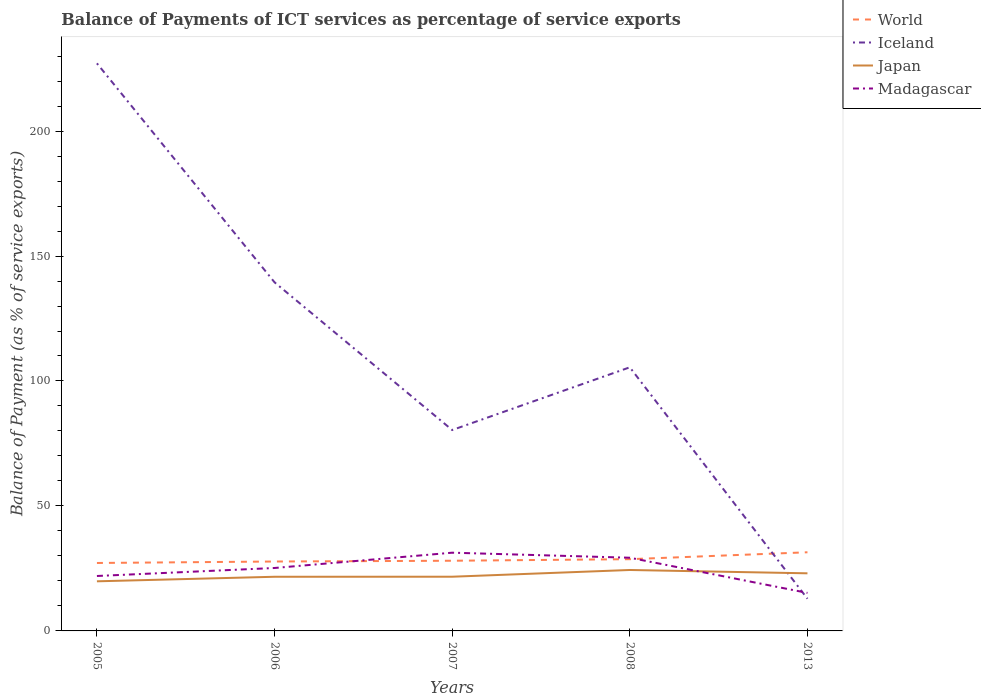Is the number of lines equal to the number of legend labels?
Offer a terse response. Yes. Across all years, what is the maximum balance of payments of ICT services in Japan?
Ensure brevity in your answer.  19.85. What is the total balance of payments of ICT services in Madagascar in the graph?
Keep it short and to the point. -9.32. What is the difference between the highest and the second highest balance of payments of ICT services in Madagascar?
Your answer should be very brief. 16.09. Are the values on the major ticks of Y-axis written in scientific E-notation?
Your answer should be very brief. No. Where does the legend appear in the graph?
Provide a short and direct response. Top right. What is the title of the graph?
Provide a short and direct response. Balance of Payments of ICT services as percentage of service exports. Does "St. Kitts and Nevis" appear as one of the legend labels in the graph?
Provide a succinct answer. No. What is the label or title of the X-axis?
Keep it short and to the point. Years. What is the label or title of the Y-axis?
Provide a short and direct response. Balance of Payment (as % of service exports). What is the Balance of Payment (as % of service exports) in World in 2005?
Your answer should be very brief. 27.19. What is the Balance of Payment (as % of service exports) of Iceland in 2005?
Ensure brevity in your answer.  227.09. What is the Balance of Payment (as % of service exports) in Japan in 2005?
Ensure brevity in your answer.  19.85. What is the Balance of Payment (as % of service exports) in Madagascar in 2005?
Offer a very short reply. 21.98. What is the Balance of Payment (as % of service exports) of World in 2006?
Ensure brevity in your answer.  27.77. What is the Balance of Payment (as % of service exports) of Iceland in 2006?
Offer a very short reply. 139.47. What is the Balance of Payment (as % of service exports) of Japan in 2006?
Provide a succinct answer. 21.67. What is the Balance of Payment (as % of service exports) of Madagascar in 2006?
Give a very brief answer. 25.18. What is the Balance of Payment (as % of service exports) in World in 2007?
Provide a short and direct response. 28.08. What is the Balance of Payment (as % of service exports) of Iceland in 2007?
Offer a very short reply. 80.38. What is the Balance of Payment (as % of service exports) of Japan in 2007?
Your answer should be compact. 21.69. What is the Balance of Payment (as % of service exports) in Madagascar in 2007?
Provide a succinct answer. 31.3. What is the Balance of Payment (as % of service exports) of World in 2008?
Your answer should be compact. 28.7. What is the Balance of Payment (as % of service exports) in Iceland in 2008?
Your answer should be very brief. 105.47. What is the Balance of Payment (as % of service exports) of Japan in 2008?
Offer a very short reply. 24.38. What is the Balance of Payment (as % of service exports) of Madagascar in 2008?
Offer a terse response. 29.28. What is the Balance of Payment (as % of service exports) in World in 2013?
Give a very brief answer. 31.47. What is the Balance of Payment (as % of service exports) of Iceland in 2013?
Your answer should be very brief. 12.89. What is the Balance of Payment (as % of service exports) in Japan in 2013?
Ensure brevity in your answer.  23.05. What is the Balance of Payment (as % of service exports) of Madagascar in 2013?
Your response must be concise. 15.21. Across all years, what is the maximum Balance of Payment (as % of service exports) in World?
Your answer should be compact. 31.47. Across all years, what is the maximum Balance of Payment (as % of service exports) of Iceland?
Your answer should be compact. 227.09. Across all years, what is the maximum Balance of Payment (as % of service exports) of Japan?
Offer a very short reply. 24.38. Across all years, what is the maximum Balance of Payment (as % of service exports) of Madagascar?
Make the answer very short. 31.3. Across all years, what is the minimum Balance of Payment (as % of service exports) of World?
Your response must be concise. 27.19. Across all years, what is the minimum Balance of Payment (as % of service exports) in Iceland?
Keep it short and to the point. 12.89. Across all years, what is the minimum Balance of Payment (as % of service exports) of Japan?
Your answer should be very brief. 19.85. Across all years, what is the minimum Balance of Payment (as % of service exports) in Madagascar?
Provide a short and direct response. 15.21. What is the total Balance of Payment (as % of service exports) in World in the graph?
Give a very brief answer. 143.21. What is the total Balance of Payment (as % of service exports) of Iceland in the graph?
Offer a terse response. 565.31. What is the total Balance of Payment (as % of service exports) of Japan in the graph?
Offer a very short reply. 110.63. What is the total Balance of Payment (as % of service exports) in Madagascar in the graph?
Give a very brief answer. 122.95. What is the difference between the Balance of Payment (as % of service exports) in World in 2005 and that in 2006?
Offer a terse response. -0.59. What is the difference between the Balance of Payment (as % of service exports) in Iceland in 2005 and that in 2006?
Offer a very short reply. 87.62. What is the difference between the Balance of Payment (as % of service exports) in Japan in 2005 and that in 2006?
Your response must be concise. -1.82. What is the difference between the Balance of Payment (as % of service exports) of Madagascar in 2005 and that in 2006?
Offer a terse response. -3.2. What is the difference between the Balance of Payment (as % of service exports) in World in 2005 and that in 2007?
Your answer should be very brief. -0.9. What is the difference between the Balance of Payment (as % of service exports) of Iceland in 2005 and that in 2007?
Provide a succinct answer. 146.71. What is the difference between the Balance of Payment (as % of service exports) of Japan in 2005 and that in 2007?
Your response must be concise. -1.84. What is the difference between the Balance of Payment (as % of service exports) in Madagascar in 2005 and that in 2007?
Offer a terse response. -9.32. What is the difference between the Balance of Payment (as % of service exports) in World in 2005 and that in 2008?
Ensure brevity in your answer.  -1.52. What is the difference between the Balance of Payment (as % of service exports) of Iceland in 2005 and that in 2008?
Your answer should be very brief. 121.62. What is the difference between the Balance of Payment (as % of service exports) in Japan in 2005 and that in 2008?
Your answer should be compact. -4.53. What is the difference between the Balance of Payment (as % of service exports) in Madagascar in 2005 and that in 2008?
Make the answer very short. -7.31. What is the difference between the Balance of Payment (as % of service exports) of World in 2005 and that in 2013?
Offer a terse response. -4.28. What is the difference between the Balance of Payment (as % of service exports) of Iceland in 2005 and that in 2013?
Offer a very short reply. 214.2. What is the difference between the Balance of Payment (as % of service exports) in Japan in 2005 and that in 2013?
Give a very brief answer. -3.2. What is the difference between the Balance of Payment (as % of service exports) of Madagascar in 2005 and that in 2013?
Provide a short and direct response. 6.77. What is the difference between the Balance of Payment (as % of service exports) of World in 2006 and that in 2007?
Your answer should be very brief. -0.31. What is the difference between the Balance of Payment (as % of service exports) of Iceland in 2006 and that in 2007?
Provide a short and direct response. 59.09. What is the difference between the Balance of Payment (as % of service exports) in Japan in 2006 and that in 2007?
Your answer should be compact. -0.02. What is the difference between the Balance of Payment (as % of service exports) of Madagascar in 2006 and that in 2007?
Offer a very short reply. -6.12. What is the difference between the Balance of Payment (as % of service exports) of World in 2006 and that in 2008?
Keep it short and to the point. -0.93. What is the difference between the Balance of Payment (as % of service exports) in Iceland in 2006 and that in 2008?
Ensure brevity in your answer.  34. What is the difference between the Balance of Payment (as % of service exports) in Japan in 2006 and that in 2008?
Offer a very short reply. -2.72. What is the difference between the Balance of Payment (as % of service exports) in Madagascar in 2006 and that in 2008?
Give a very brief answer. -4.1. What is the difference between the Balance of Payment (as % of service exports) of World in 2006 and that in 2013?
Offer a very short reply. -3.7. What is the difference between the Balance of Payment (as % of service exports) in Iceland in 2006 and that in 2013?
Give a very brief answer. 126.59. What is the difference between the Balance of Payment (as % of service exports) in Japan in 2006 and that in 2013?
Offer a terse response. -1.38. What is the difference between the Balance of Payment (as % of service exports) of Madagascar in 2006 and that in 2013?
Ensure brevity in your answer.  9.97. What is the difference between the Balance of Payment (as % of service exports) in World in 2007 and that in 2008?
Give a very brief answer. -0.62. What is the difference between the Balance of Payment (as % of service exports) in Iceland in 2007 and that in 2008?
Offer a terse response. -25.09. What is the difference between the Balance of Payment (as % of service exports) in Japan in 2007 and that in 2008?
Offer a terse response. -2.7. What is the difference between the Balance of Payment (as % of service exports) in Madagascar in 2007 and that in 2008?
Your response must be concise. 2.02. What is the difference between the Balance of Payment (as % of service exports) of World in 2007 and that in 2013?
Your response must be concise. -3.39. What is the difference between the Balance of Payment (as % of service exports) in Iceland in 2007 and that in 2013?
Provide a short and direct response. 67.5. What is the difference between the Balance of Payment (as % of service exports) of Japan in 2007 and that in 2013?
Your answer should be compact. -1.36. What is the difference between the Balance of Payment (as % of service exports) of Madagascar in 2007 and that in 2013?
Your response must be concise. 16.09. What is the difference between the Balance of Payment (as % of service exports) in World in 2008 and that in 2013?
Make the answer very short. -2.77. What is the difference between the Balance of Payment (as % of service exports) of Iceland in 2008 and that in 2013?
Offer a very short reply. 92.59. What is the difference between the Balance of Payment (as % of service exports) of Japan in 2008 and that in 2013?
Ensure brevity in your answer.  1.33. What is the difference between the Balance of Payment (as % of service exports) in Madagascar in 2008 and that in 2013?
Provide a short and direct response. 14.07. What is the difference between the Balance of Payment (as % of service exports) in World in 2005 and the Balance of Payment (as % of service exports) in Iceland in 2006?
Ensure brevity in your answer.  -112.29. What is the difference between the Balance of Payment (as % of service exports) in World in 2005 and the Balance of Payment (as % of service exports) in Japan in 2006?
Keep it short and to the point. 5.52. What is the difference between the Balance of Payment (as % of service exports) of World in 2005 and the Balance of Payment (as % of service exports) of Madagascar in 2006?
Ensure brevity in your answer.  2. What is the difference between the Balance of Payment (as % of service exports) of Iceland in 2005 and the Balance of Payment (as % of service exports) of Japan in 2006?
Your answer should be compact. 205.43. What is the difference between the Balance of Payment (as % of service exports) of Iceland in 2005 and the Balance of Payment (as % of service exports) of Madagascar in 2006?
Your response must be concise. 201.91. What is the difference between the Balance of Payment (as % of service exports) in Japan in 2005 and the Balance of Payment (as % of service exports) in Madagascar in 2006?
Keep it short and to the point. -5.33. What is the difference between the Balance of Payment (as % of service exports) in World in 2005 and the Balance of Payment (as % of service exports) in Iceland in 2007?
Give a very brief answer. -53.2. What is the difference between the Balance of Payment (as % of service exports) in World in 2005 and the Balance of Payment (as % of service exports) in Japan in 2007?
Offer a very short reply. 5.5. What is the difference between the Balance of Payment (as % of service exports) of World in 2005 and the Balance of Payment (as % of service exports) of Madagascar in 2007?
Your answer should be very brief. -4.12. What is the difference between the Balance of Payment (as % of service exports) in Iceland in 2005 and the Balance of Payment (as % of service exports) in Japan in 2007?
Give a very brief answer. 205.41. What is the difference between the Balance of Payment (as % of service exports) of Iceland in 2005 and the Balance of Payment (as % of service exports) of Madagascar in 2007?
Make the answer very short. 195.79. What is the difference between the Balance of Payment (as % of service exports) of Japan in 2005 and the Balance of Payment (as % of service exports) of Madagascar in 2007?
Your answer should be compact. -11.45. What is the difference between the Balance of Payment (as % of service exports) in World in 2005 and the Balance of Payment (as % of service exports) in Iceland in 2008?
Offer a terse response. -78.29. What is the difference between the Balance of Payment (as % of service exports) of World in 2005 and the Balance of Payment (as % of service exports) of Japan in 2008?
Provide a short and direct response. 2.8. What is the difference between the Balance of Payment (as % of service exports) of World in 2005 and the Balance of Payment (as % of service exports) of Madagascar in 2008?
Provide a succinct answer. -2.1. What is the difference between the Balance of Payment (as % of service exports) of Iceland in 2005 and the Balance of Payment (as % of service exports) of Japan in 2008?
Your response must be concise. 202.71. What is the difference between the Balance of Payment (as % of service exports) of Iceland in 2005 and the Balance of Payment (as % of service exports) of Madagascar in 2008?
Provide a short and direct response. 197.81. What is the difference between the Balance of Payment (as % of service exports) in Japan in 2005 and the Balance of Payment (as % of service exports) in Madagascar in 2008?
Provide a succinct answer. -9.43. What is the difference between the Balance of Payment (as % of service exports) in World in 2005 and the Balance of Payment (as % of service exports) in Iceland in 2013?
Your answer should be compact. 14.3. What is the difference between the Balance of Payment (as % of service exports) in World in 2005 and the Balance of Payment (as % of service exports) in Japan in 2013?
Your answer should be compact. 4.14. What is the difference between the Balance of Payment (as % of service exports) of World in 2005 and the Balance of Payment (as % of service exports) of Madagascar in 2013?
Your answer should be very brief. 11.97. What is the difference between the Balance of Payment (as % of service exports) of Iceland in 2005 and the Balance of Payment (as % of service exports) of Japan in 2013?
Provide a succinct answer. 204.04. What is the difference between the Balance of Payment (as % of service exports) in Iceland in 2005 and the Balance of Payment (as % of service exports) in Madagascar in 2013?
Offer a terse response. 211.88. What is the difference between the Balance of Payment (as % of service exports) in Japan in 2005 and the Balance of Payment (as % of service exports) in Madagascar in 2013?
Offer a very short reply. 4.64. What is the difference between the Balance of Payment (as % of service exports) of World in 2006 and the Balance of Payment (as % of service exports) of Iceland in 2007?
Keep it short and to the point. -52.61. What is the difference between the Balance of Payment (as % of service exports) in World in 2006 and the Balance of Payment (as % of service exports) in Japan in 2007?
Your answer should be very brief. 6.08. What is the difference between the Balance of Payment (as % of service exports) in World in 2006 and the Balance of Payment (as % of service exports) in Madagascar in 2007?
Make the answer very short. -3.53. What is the difference between the Balance of Payment (as % of service exports) in Iceland in 2006 and the Balance of Payment (as % of service exports) in Japan in 2007?
Make the answer very short. 117.79. What is the difference between the Balance of Payment (as % of service exports) in Iceland in 2006 and the Balance of Payment (as % of service exports) in Madagascar in 2007?
Provide a short and direct response. 108.17. What is the difference between the Balance of Payment (as % of service exports) of Japan in 2006 and the Balance of Payment (as % of service exports) of Madagascar in 2007?
Your response must be concise. -9.63. What is the difference between the Balance of Payment (as % of service exports) in World in 2006 and the Balance of Payment (as % of service exports) in Iceland in 2008?
Offer a very short reply. -77.7. What is the difference between the Balance of Payment (as % of service exports) in World in 2006 and the Balance of Payment (as % of service exports) in Japan in 2008?
Provide a succinct answer. 3.39. What is the difference between the Balance of Payment (as % of service exports) in World in 2006 and the Balance of Payment (as % of service exports) in Madagascar in 2008?
Your answer should be very brief. -1.51. What is the difference between the Balance of Payment (as % of service exports) in Iceland in 2006 and the Balance of Payment (as % of service exports) in Japan in 2008?
Ensure brevity in your answer.  115.09. What is the difference between the Balance of Payment (as % of service exports) in Iceland in 2006 and the Balance of Payment (as % of service exports) in Madagascar in 2008?
Keep it short and to the point. 110.19. What is the difference between the Balance of Payment (as % of service exports) of Japan in 2006 and the Balance of Payment (as % of service exports) of Madagascar in 2008?
Offer a terse response. -7.62. What is the difference between the Balance of Payment (as % of service exports) of World in 2006 and the Balance of Payment (as % of service exports) of Iceland in 2013?
Make the answer very short. 14.88. What is the difference between the Balance of Payment (as % of service exports) of World in 2006 and the Balance of Payment (as % of service exports) of Japan in 2013?
Your answer should be compact. 4.72. What is the difference between the Balance of Payment (as % of service exports) of World in 2006 and the Balance of Payment (as % of service exports) of Madagascar in 2013?
Give a very brief answer. 12.56. What is the difference between the Balance of Payment (as % of service exports) of Iceland in 2006 and the Balance of Payment (as % of service exports) of Japan in 2013?
Offer a terse response. 116.43. What is the difference between the Balance of Payment (as % of service exports) of Iceland in 2006 and the Balance of Payment (as % of service exports) of Madagascar in 2013?
Your response must be concise. 124.26. What is the difference between the Balance of Payment (as % of service exports) in Japan in 2006 and the Balance of Payment (as % of service exports) in Madagascar in 2013?
Offer a very short reply. 6.46. What is the difference between the Balance of Payment (as % of service exports) of World in 2007 and the Balance of Payment (as % of service exports) of Iceland in 2008?
Provide a short and direct response. -77.39. What is the difference between the Balance of Payment (as % of service exports) in World in 2007 and the Balance of Payment (as % of service exports) in Japan in 2008?
Your answer should be compact. 3.7. What is the difference between the Balance of Payment (as % of service exports) in World in 2007 and the Balance of Payment (as % of service exports) in Madagascar in 2008?
Your answer should be very brief. -1.2. What is the difference between the Balance of Payment (as % of service exports) of Iceland in 2007 and the Balance of Payment (as % of service exports) of Japan in 2008?
Your answer should be very brief. 56. What is the difference between the Balance of Payment (as % of service exports) in Iceland in 2007 and the Balance of Payment (as % of service exports) in Madagascar in 2008?
Keep it short and to the point. 51.1. What is the difference between the Balance of Payment (as % of service exports) in Japan in 2007 and the Balance of Payment (as % of service exports) in Madagascar in 2008?
Your response must be concise. -7.6. What is the difference between the Balance of Payment (as % of service exports) of World in 2007 and the Balance of Payment (as % of service exports) of Iceland in 2013?
Your answer should be very brief. 15.19. What is the difference between the Balance of Payment (as % of service exports) in World in 2007 and the Balance of Payment (as % of service exports) in Japan in 2013?
Your answer should be very brief. 5.03. What is the difference between the Balance of Payment (as % of service exports) in World in 2007 and the Balance of Payment (as % of service exports) in Madagascar in 2013?
Ensure brevity in your answer.  12.87. What is the difference between the Balance of Payment (as % of service exports) of Iceland in 2007 and the Balance of Payment (as % of service exports) of Japan in 2013?
Provide a short and direct response. 57.34. What is the difference between the Balance of Payment (as % of service exports) in Iceland in 2007 and the Balance of Payment (as % of service exports) in Madagascar in 2013?
Your response must be concise. 65.17. What is the difference between the Balance of Payment (as % of service exports) in Japan in 2007 and the Balance of Payment (as % of service exports) in Madagascar in 2013?
Give a very brief answer. 6.47. What is the difference between the Balance of Payment (as % of service exports) of World in 2008 and the Balance of Payment (as % of service exports) of Iceland in 2013?
Keep it short and to the point. 15.81. What is the difference between the Balance of Payment (as % of service exports) of World in 2008 and the Balance of Payment (as % of service exports) of Japan in 2013?
Ensure brevity in your answer.  5.65. What is the difference between the Balance of Payment (as % of service exports) of World in 2008 and the Balance of Payment (as % of service exports) of Madagascar in 2013?
Your answer should be very brief. 13.49. What is the difference between the Balance of Payment (as % of service exports) in Iceland in 2008 and the Balance of Payment (as % of service exports) in Japan in 2013?
Make the answer very short. 82.43. What is the difference between the Balance of Payment (as % of service exports) of Iceland in 2008 and the Balance of Payment (as % of service exports) of Madagascar in 2013?
Offer a very short reply. 90.26. What is the difference between the Balance of Payment (as % of service exports) of Japan in 2008 and the Balance of Payment (as % of service exports) of Madagascar in 2013?
Offer a terse response. 9.17. What is the average Balance of Payment (as % of service exports) of World per year?
Your answer should be very brief. 28.64. What is the average Balance of Payment (as % of service exports) of Iceland per year?
Your answer should be very brief. 113.06. What is the average Balance of Payment (as % of service exports) of Japan per year?
Keep it short and to the point. 22.13. What is the average Balance of Payment (as % of service exports) of Madagascar per year?
Your response must be concise. 24.59. In the year 2005, what is the difference between the Balance of Payment (as % of service exports) of World and Balance of Payment (as % of service exports) of Iceland?
Your answer should be compact. -199.91. In the year 2005, what is the difference between the Balance of Payment (as % of service exports) in World and Balance of Payment (as % of service exports) in Japan?
Your answer should be very brief. 7.34. In the year 2005, what is the difference between the Balance of Payment (as % of service exports) in World and Balance of Payment (as % of service exports) in Madagascar?
Your answer should be compact. 5.21. In the year 2005, what is the difference between the Balance of Payment (as % of service exports) in Iceland and Balance of Payment (as % of service exports) in Japan?
Provide a short and direct response. 207.24. In the year 2005, what is the difference between the Balance of Payment (as % of service exports) in Iceland and Balance of Payment (as % of service exports) in Madagascar?
Make the answer very short. 205.11. In the year 2005, what is the difference between the Balance of Payment (as % of service exports) in Japan and Balance of Payment (as % of service exports) in Madagascar?
Your response must be concise. -2.13. In the year 2006, what is the difference between the Balance of Payment (as % of service exports) of World and Balance of Payment (as % of service exports) of Iceland?
Provide a short and direct response. -111.7. In the year 2006, what is the difference between the Balance of Payment (as % of service exports) in World and Balance of Payment (as % of service exports) in Japan?
Ensure brevity in your answer.  6.1. In the year 2006, what is the difference between the Balance of Payment (as % of service exports) in World and Balance of Payment (as % of service exports) in Madagascar?
Your answer should be compact. 2.59. In the year 2006, what is the difference between the Balance of Payment (as % of service exports) of Iceland and Balance of Payment (as % of service exports) of Japan?
Your answer should be compact. 117.81. In the year 2006, what is the difference between the Balance of Payment (as % of service exports) of Iceland and Balance of Payment (as % of service exports) of Madagascar?
Your answer should be compact. 114.29. In the year 2006, what is the difference between the Balance of Payment (as % of service exports) in Japan and Balance of Payment (as % of service exports) in Madagascar?
Give a very brief answer. -3.51. In the year 2007, what is the difference between the Balance of Payment (as % of service exports) of World and Balance of Payment (as % of service exports) of Iceland?
Your answer should be very brief. -52.3. In the year 2007, what is the difference between the Balance of Payment (as % of service exports) in World and Balance of Payment (as % of service exports) in Japan?
Offer a very short reply. 6.39. In the year 2007, what is the difference between the Balance of Payment (as % of service exports) in World and Balance of Payment (as % of service exports) in Madagascar?
Provide a succinct answer. -3.22. In the year 2007, what is the difference between the Balance of Payment (as % of service exports) in Iceland and Balance of Payment (as % of service exports) in Japan?
Your answer should be very brief. 58.7. In the year 2007, what is the difference between the Balance of Payment (as % of service exports) in Iceland and Balance of Payment (as % of service exports) in Madagascar?
Offer a very short reply. 49.08. In the year 2007, what is the difference between the Balance of Payment (as % of service exports) of Japan and Balance of Payment (as % of service exports) of Madagascar?
Provide a succinct answer. -9.62. In the year 2008, what is the difference between the Balance of Payment (as % of service exports) in World and Balance of Payment (as % of service exports) in Iceland?
Your answer should be very brief. -76.77. In the year 2008, what is the difference between the Balance of Payment (as % of service exports) in World and Balance of Payment (as % of service exports) in Japan?
Ensure brevity in your answer.  4.32. In the year 2008, what is the difference between the Balance of Payment (as % of service exports) in World and Balance of Payment (as % of service exports) in Madagascar?
Ensure brevity in your answer.  -0.58. In the year 2008, what is the difference between the Balance of Payment (as % of service exports) of Iceland and Balance of Payment (as % of service exports) of Japan?
Provide a succinct answer. 81.09. In the year 2008, what is the difference between the Balance of Payment (as % of service exports) in Iceland and Balance of Payment (as % of service exports) in Madagascar?
Offer a terse response. 76.19. In the year 2008, what is the difference between the Balance of Payment (as % of service exports) of Japan and Balance of Payment (as % of service exports) of Madagascar?
Provide a succinct answer. -4.9. In the year 2013, what is the difference between the Balance of Payment (as % of service exports) in World and Balance of Payment (as % of service exports) in Iceland?
Provide a short and direct response. 18.58. In the year 2013, what is the difference between the Balance of Payment (as % of service exports) of World and Balance of Payment (as % of service exports) of Japan?
Ensure brevity in your answer.  8.42. In the year 2013, what is the difference between the Balance of Payment (as % of service exports) of World and Balance of Payment (as % of service exports) of Madagascar?
Offer a very short reply. 16.26. In the year 2013, what is the difference between the Balance of Payment (as % of service exports) of Iceland and Balance of Payment (as % of service exports) of Japan?
Provide a short and direct response. -10.16. In the year 2013, what is the difference between the Balance of Payment (as % of service exports) of Iceland and Balance of Payment (as % of service exports) of Madagascar?
Ensure brevity in your answer.  -2.32. In the year 2013, what is the difference between the Balance of Payment (as % of service exports) in Japan and Balance of Payment (as % of service exports) in Madagascar?
Your answer should be compact. 7.84. What is the ratio of the Balance of Payment (as % of service exports) of World in 2005 to that in 2006?
Provide a short and direct response. 0.98. What is the ratio of the Balance of Payment (as % of service exports) in Iceland in 2005 to that in 2006?
Your answer should be compact. 1.63. What is the ratio of the Balance of Payment (as % of service exports) of Japan in 2005 to that in 2006?
Offer a terse response. 0.92. What is the ratio of the Balance of Payment (as % of service exports) of Madagascar in 2005 to that in 2006?
Make the answer very short. 0.87. What is the ratio of the Balance of Payment (as % of service exports) in World in 2005 to that in 2007?
Your answer should be compact. 0.97. What is the ratio of the Balance of Payment (as % of service exports) in Iceland in 2005 to that in 2007?
Your response must be concise. 2.83. What is the ratio of the Balance of Payment (as % of service exports) of Japan in 2005 to that in 2007?
Your answer should be very brief. 0.92. What is the ratio of the Balance of Payment (as % of service exports) in Madagascar in 2005 to that in 2007?
Offer a very short reply. 0.7. What is the ratio of the Balance of Payment (as % of service exports) of World in 2005 to that in 2008?
Keep it short and to the point. 0.95. What is the ratio of the Balance of Payment (as % of service exports) of Iceland in 2005 to that in 2008?
Provide a short and direct response. 2.15. What is the ratio of the Balance of Payment (as % of service exports) of Japan in 2005 to that in 2008?
Provide a short and direct response. 0.81. What is the ratio of the Balance of Payment (as % of service exports) in Madagascar in 2005 to that in 2008?
Your answer should be compact. 0.75. What is the ratio of the Balance of Payment (as % of service exports) of World in 2005 to that in 2013?
Ensure brevity in your answer.  0.86. What is the ratio of the Balance of Payment (as % of service exports) in Iceland in 2005 to that in 2013?
Your answer should be compact. 17.62. What is the ratio of the Balance of Payment (as % of service exports) of Japan in 2005 to that in 2013?
Offer a very short reply. 0.86. What is the ratio of the Balance of Payment (as % of service exports) in Madagascar in 2005 to that in 2013?
Make the answer very short. 1.44. What is the ratio of the Balance of Payment (as % of service exports) in Iceland in 2006 to that in 2007?
Provide a succinct answer. 1.74. What is the ratio of the Balance of Payment (as % of service exports) in Madagascar in 2006 to that in 2007?
Your answer should be very brief. 0.8. What is the ratio of the Balance of Payment (as % of service exports) in World in 2006 to that in 2008?
Give a very brief answer. 0.97. What is the ratio of the Balance of Payment (as % of service exports) in Iceland in 2006 to that in 2008?
Your response must be concise. 1.32. What is the ratio of the Balance of Payment (as % of service exports) of Japan in 2006 to that in 2008?
Your answer should be compact. 0.89. What is the ratio of the Balance of Payment (as % of service exports) of Madagascar in 2006 to that in 2008?
Provide a short and direct response. 0.86. What is the ratio of the Balance of Payment (as % of service exports) in World in 2006 to that in 2013?
Give a very brief answer. 0.88. What is the ratio of the Balance of Payment (as % of service exports) of Iceland in 2006 to that in 2013?
Provide a short and direct response. 10.82. What is the ratio of the Balance of Payment (as % of service exports) of Japan in 2006 to that in 2013?
Make the answer very short. 0.94. What is the ratio of the Balance of Payment (as % of service exports) in Madagascar in 2006 to that in 2013?
Ensure brevity in your answer.  1.66. What is the ratio of the Balance of Payment (as % of service exports) of World in 2007 to that in 2008?
Your answer should be compact. 0.98. What is the ratio of the Balance of Payment (as % of service exports) of Iceland in 2007 to that in 2008?
Offer a terse response. 0.76. What is the ratio of the Balance of Payment (as % of service exports) in Japan in 2007 to that in 2008?
Make the answer very short. 0.89. What is the ratio of the Balance of Payment (as % of service exports) in Madagascar in 2007 to that in 2008?
Make the answer very short. 1.07. What is the ratio of the Balance of Payment (as % of service exports) in World in 2007 to that in 2013?
Your response must be concise. 0.89. What is the ratio of the Balance of Payment (as % of service exports) in Iceland in 2007 to that in 2013?
Give a very brief answer. 6.24. What is the ratio of the Balance of Payment (as % of service exports) of Japan in 2007 to that in 2013?
Your answer should be very brief. 0.94. What is the ratio of the Balance of Payment (as % of service exports) in Madagascar in 2007 to that in 2013?
Give a very brief answer. 2.06. What is the ratio of the Balance of Payment (as % of service exports) in World in 2008 to that in 2013?
Your response must be concise. 0.91. What is the ratio of the Balance of Payment (as % of service exports) in Iceland in 2008 to that in 2013?
Keep it short and to the point. 8.18. What is the ratio of the Balance of Payment (as % of service exports) in Japan in 2008 to that in 2013?
Provide a short and direct response. 1.06. What is the ratio of the Balance of Payment (as % of service exports) of Madagascar in 2008 to that in 2013?
Your answer should be very brief. 1.93. What is the difference between the highest and the second highest Balance of Payment (as % of service exports) of World?
Your answer should be compact. 2.77. What is the difference between the highest and the second highest Balance of Payment (as % of service exports) in Iceland?
Make the answer very short. 87.62. What is the difference between the highest and the second highest Balance of Payment (as % of service exports) in Japan?
Give a very brief answer. 1.33. What is the difference between the highest and the second highest Balance of Payment (as % of service exports) in Madagascar?
Provide a succinct answer. 2.02. What is the difference between the highest and the lowest Balance of Payment (as % of service exports) of World?
Your answer should be very brief. 4.28. What is the difference between the highest and the lowest Balance of Payment (as % of service exports) in Iceland?
Make the answer very short. 214.2. What is the difference between the highest and the lowest Balance of Payment (as % of service exports) in Japan?
Offer a terse response. 4.53. What is the difference between the highest and the lowest Balance of Payment (as % of service exports) in Madagascar?
Your answer should be compact. 16.09. 